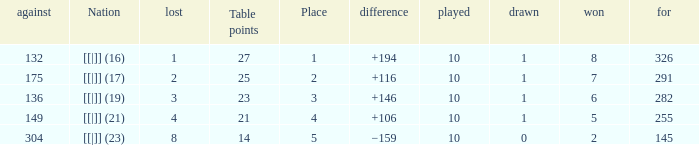 How many table points are listed for the deficit is +194?  1.0. 